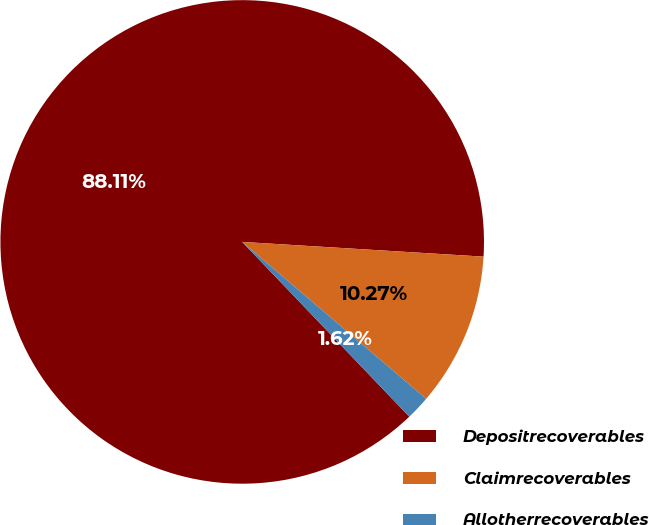Convert chart to OTSL. <chart><loc_0><loc_0><loc_500><loc_500><pie_chart><fcel>Depositrecoverables<fcel>Claimrecoverables<fcel>Allotherrecoverables<nl><fcel>88.12%<fcel>10.27%<fcel>1.62%<nl></chart> 